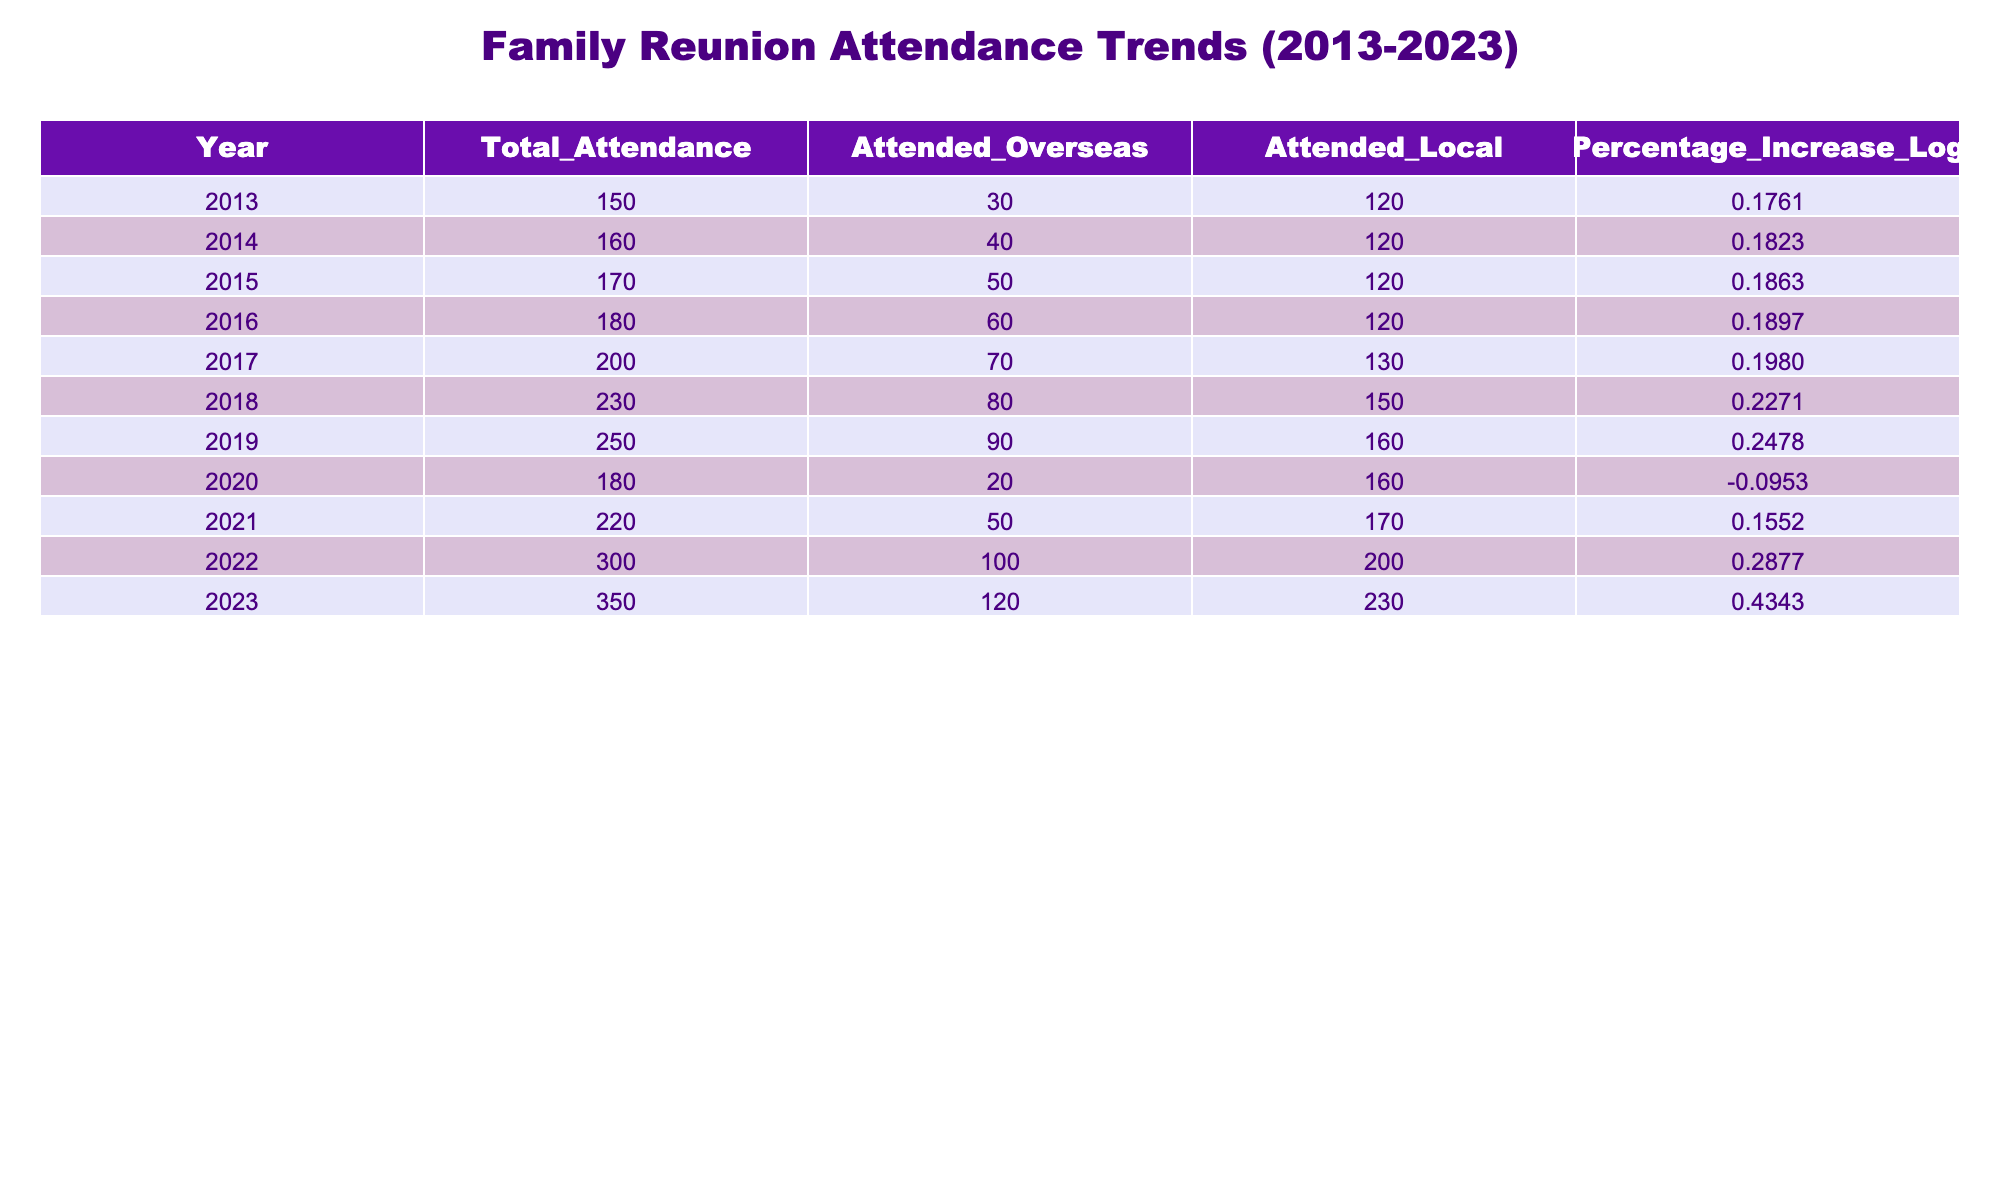What was the total attendance in 2019? From the table, the total attendance in the year 2019 is directly listed as 250.
Answer: 250 What is the percentage increase in total attendance from 2018 to 2019? The percentage increase can be calculated by taking the attendance numbers from 2018 (230) and 2019 (250). The increase is 250 - 230 = 20. The percentage increase is (20/230) * 100, which equals approximately 8.70%.
Answer: Approximately 8.70% Did more family members attend reunions overseas in 2022 than in 2020? The values can be compared directly from the table: in 2022, 100 members attended overseas, and in 2020, only 20 attended. Since 100 is greater than 20, the statement is true.
Answer: Yes What was the total attendance in 2023 compared to 2013? The total attendance in 2023 is 350, and in 2013, it was 150. The difference is 350 - 150 = 200. The percentage increase over this period is (200/150) * 100, which is approximately 133.33%.
Answer: 133.33% What was the average attendance per year from 2013 to 2023? To find the average attendance over the eleven years, we add up all the total attendance values: 150 + 160 + 170 + 180 + 200 + 230 + 250 + 180 + 220 + 300 + 350 = 2390. Then divide by 11: 2390 / 11 is approximately 217.27.
Answer: Approximately 217.27 What year saw the highest percentage increase in attendance logs? By examining the 'Percentage Increase Log' column, the highest value is found in 2023 at 0.4343. This indicates that 2023 experienced the highest percentage increase in attendance compared to its previous year.
Answer: 2023 Was there a decline in total attendance from 2019 to 2020? From the table, the total attendance in 2019 is 250, and in 2020 it is 180. Since 180 is less than 250, there was a decline.
Answer: Yes What was the increase in local attendance from 2013 to 2023? Local attendance in 2013 was 120, and in 2023, it was 230. The increase is 230 - 120 = 110, indicating a significant rise in local attendance over the decade.
Answer: 110 What is the total number of overseas attendees over the entire decade? To find the total, we sum the overseas attendance: 30 + 40 + 50 + 60 + 70 + 80 + 90 + 20 + 50 + 100 + 120 = 750. Thus, the total number of overseas attendees over the decade is 750.
Answer: 750 